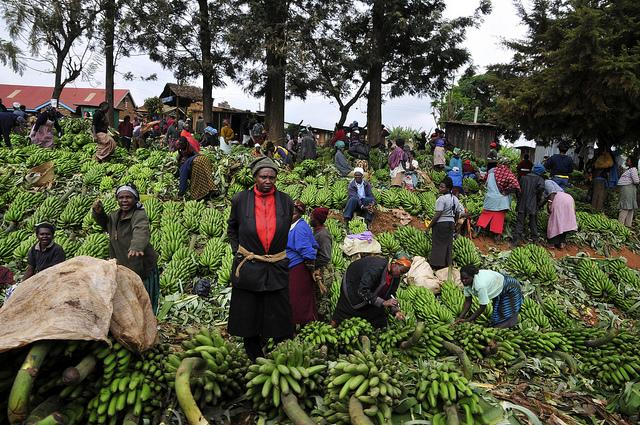What food group do these plantains belong to? fruit 